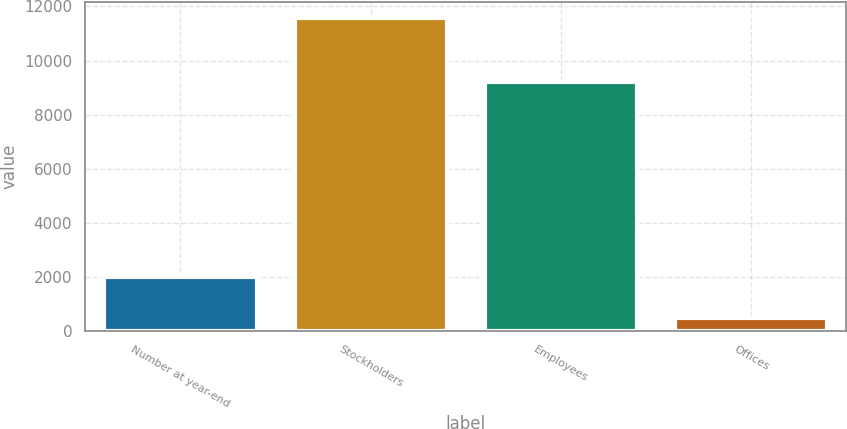Convert chart to OTSL. <chart><loc_0><loc_0><loc_500><loc_500><bar_chart><fcel>Number at year-end<fcel>Stockholders<fcel>Employees<fcel>Offices<nl><fcel>2002<fcel>11587<fcel>9197<fcel>493<nl></chart> 